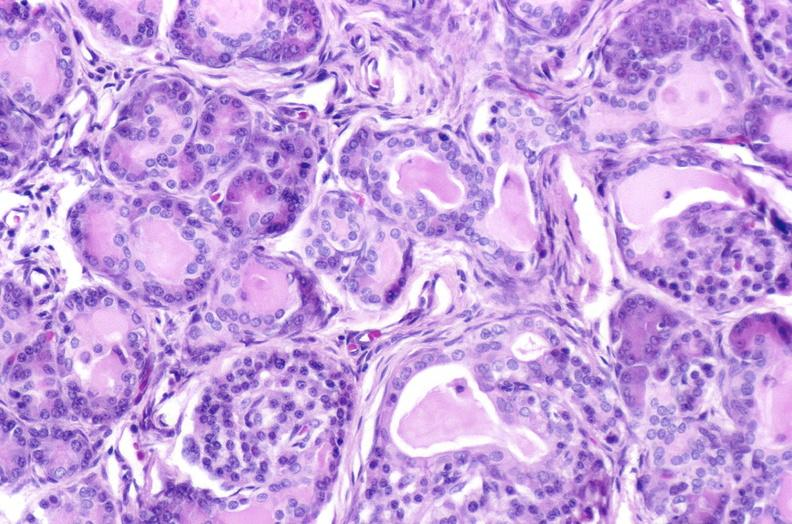what does this image show?
Answer the question using a single word or phrase. Cystic fibrosis 